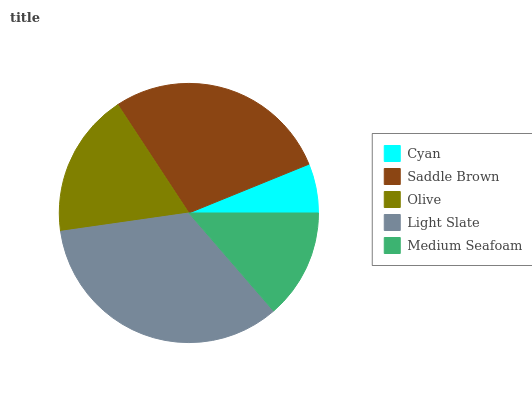Is Cyan the minimum?
Answer yes or no. Yes. Is Light Slate the maximum?
Answer yes or no. Yes. Is Saddle Brown the minimum?
Answer yes or no. No. Is Saddle Brown the maximum?
Answer yes or no. No. Is Saddle Brown greater than Cyan?
Answer yes or no. Yes. Is Cyan less than Saddle Brown?
Answer yes or no. Yes. Is Cyan greater than Saddle Brown?
Answer yes or no. No. Is Saddle Brown less than Cyan?
Answer yes or no. No. Is Olive the high median?
Answer yes or no. Yes. Is Olive the low median?
Answer yes or no. Yes. Is Medium Seafoam the high median?
Answer yes or no. No. Is Saddle Brown the low median?
Answer yes or no. No. 